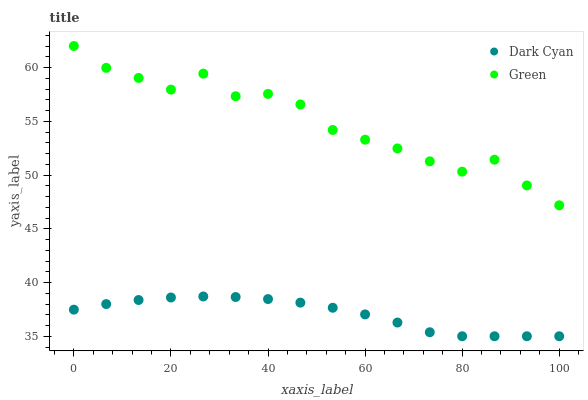Does Dark Cyan have the minimum area under the curve?
Answer yes or no. Yes. Does Green have the maximum area under the curve?
Answer yes or no. Yes. Does Green have the minimum area under the curve?
Answer yes or no. No. Is Dark Cyan the smoothest?
Answer yes or no. Yes. Is Green the roughest?
Answer yes or no. Yes. Is Green the smoothest?
Answer yes or no. No. Does Dark Cyan have the lowest value?
Answer yes or no. Yes. Does Green have the lowest value?
Answer yes or no. No. Does Green have the highest value?
Answer yes or no. Yes. Is Dark Cyan less than Green?
Answer yes or no. Yes. Is Green greater than Dark Cyan?
Answer yes or no. Yes. Does Dark Cyan intersect Green?
Answer yes or no. No. 